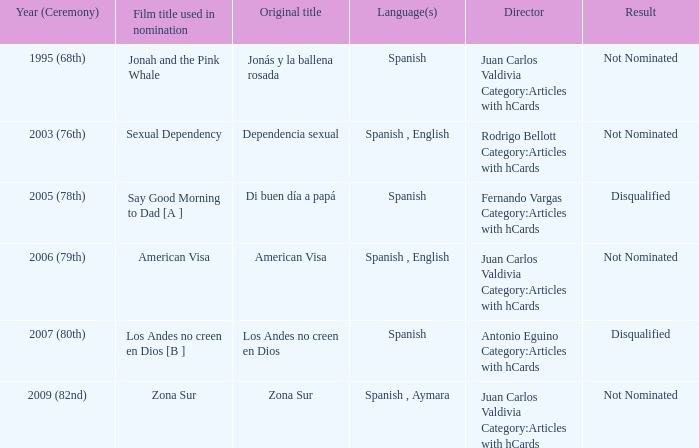What is Dependencia Sexual's film title that was used in its nomination? Sexual Dependency. 